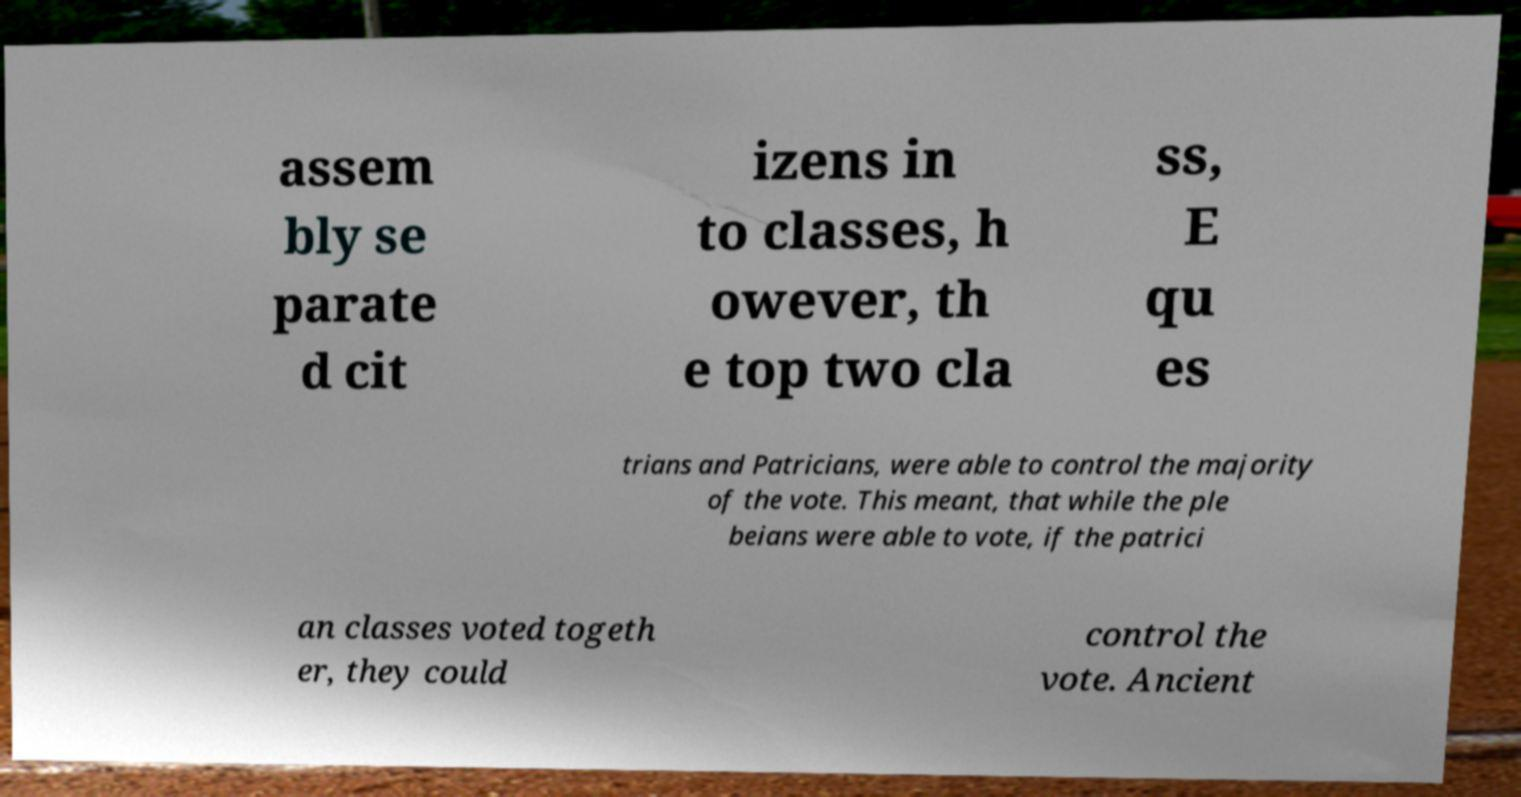There's text embedded in this image that I need extracted. Can you transcribe it verbatim? assem bly se parate d cit izens in to classes, h owever, th e top two cla ss, E qu es trians and Patricians, were able to control the majority of the vote. This meant, that while the ple beians were able to vote, if the patrici an classes voted togeth er, they could control the vote. Ancient 